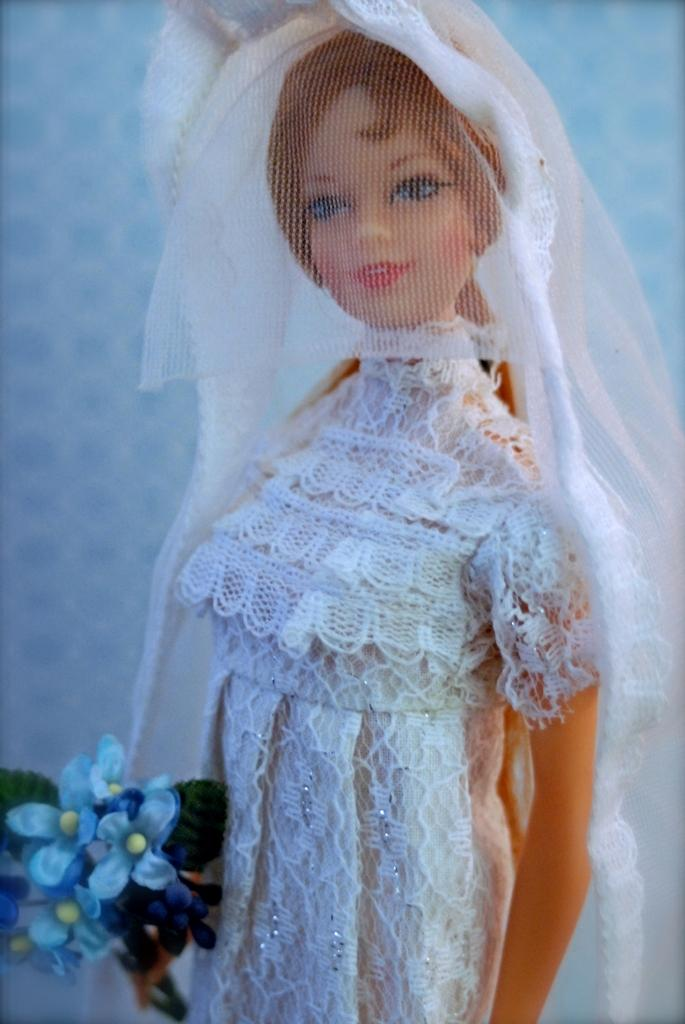What is the main subject of the image? There is a doll in the image. What is the doll wearing? The doll is wearing a dress. Does the doll have any accessories? Yes, the doll has a veil. What is the doll holding? The doll is holding a bouquet. What can be seen behind the doll? There is an object behind the doll. Can you tell me what type of dog is sitting next to the doll in the image? There is no dog present in the image; the main subject is a doll. What kind of record is the doll playing on the sofa in the image? There is no record or sofa present in the image; the doll is holding a bouquet and standing in front of an unspecified object. 